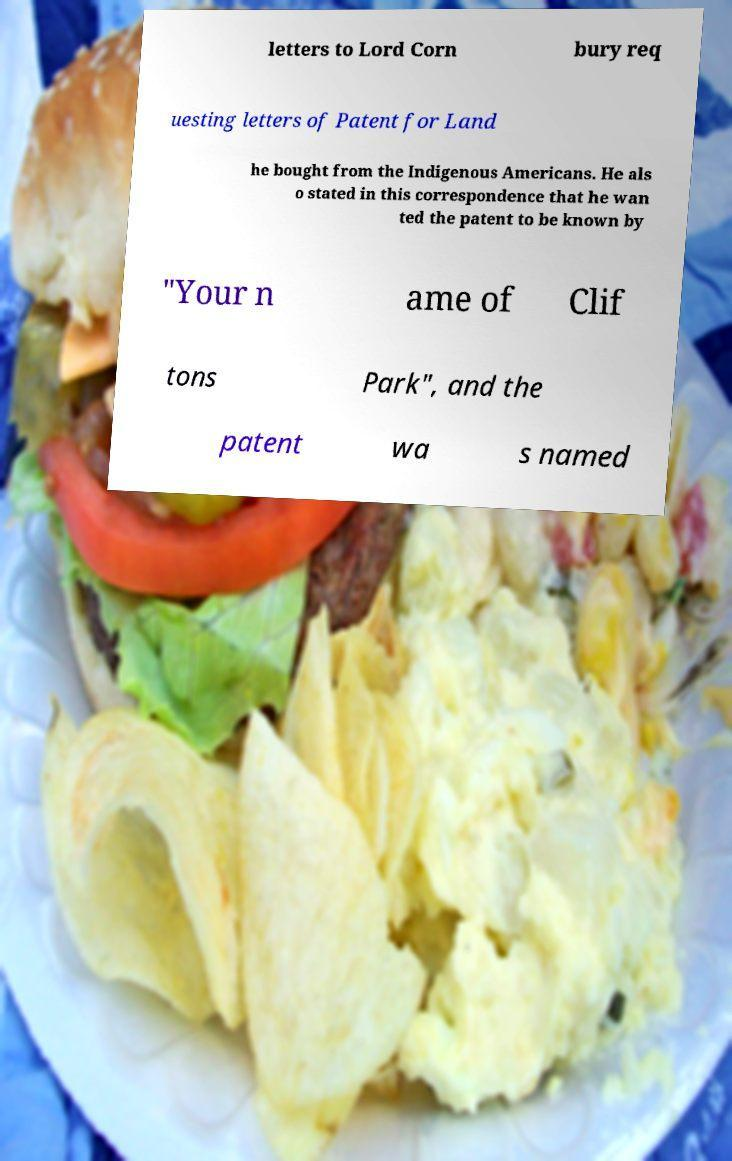Can you accurately transcribe the text from the provided image for me? letters to Lord Corn bury req uesting letters of Patent for Land he bought from the Indigenous Americans. He als o stated in this correspondence that he wan ted the patent to be known by "Your n ame of Clif tons Park", and the patent wa s named 